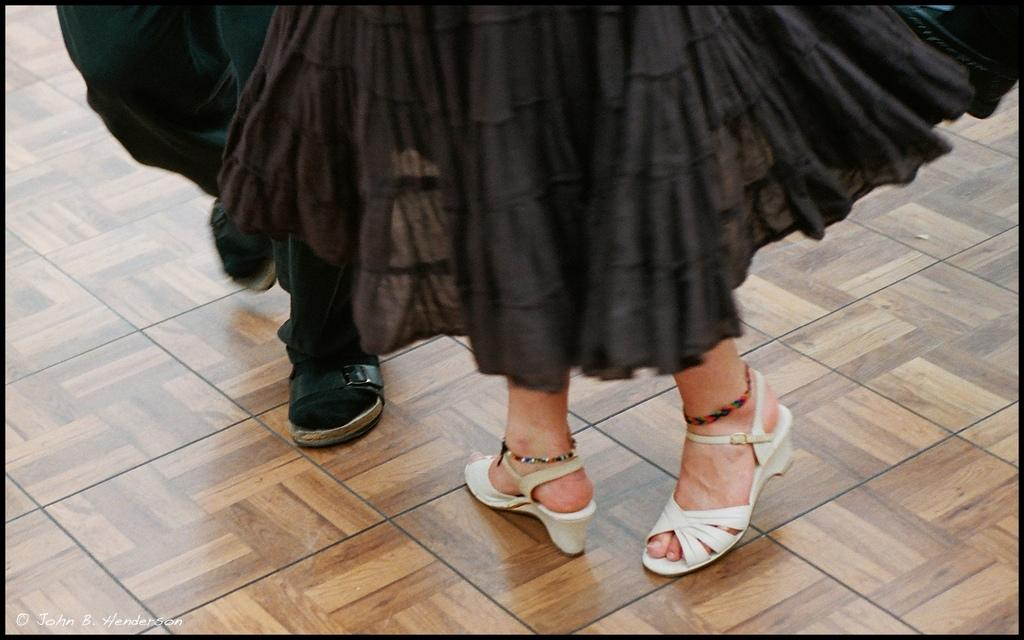What is located in the center of the image? There are legs of people in the center of the image. What type of surface is visible at the bottom of the image? There is a floor visible at the bottom of the image. What type of mark can be seen on the floor in the image? There is no mark visible on the floor in the image. What is the people in the image watching? There is no indication of what the people might be watching in the image. Is there a stream of water visible in the image? There is no stream of water present in the image. 